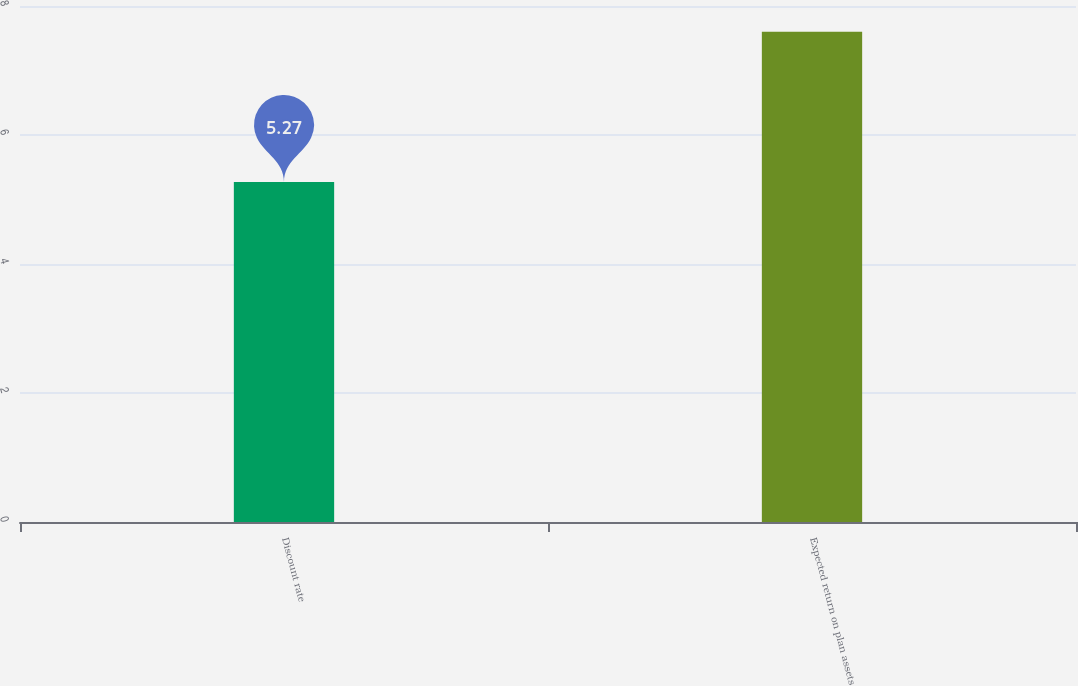<chart> <loc_0><loc_0><loc_500><loc_500><bar_chart><fcel>Discount rate<fcel>Expected return on plan assets<nl><fcel>5.27<fcel>7.6<nl></chart> 